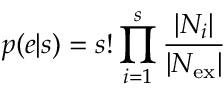Convert formula to latex. <formula><loc_0><loc_0><loc_500><loc_500>p ( e | s ) = s ! \prod _ { i = 1 } ^ { s } \frac { | N _ { i } | } { | N _ { e x } | }</formula> 